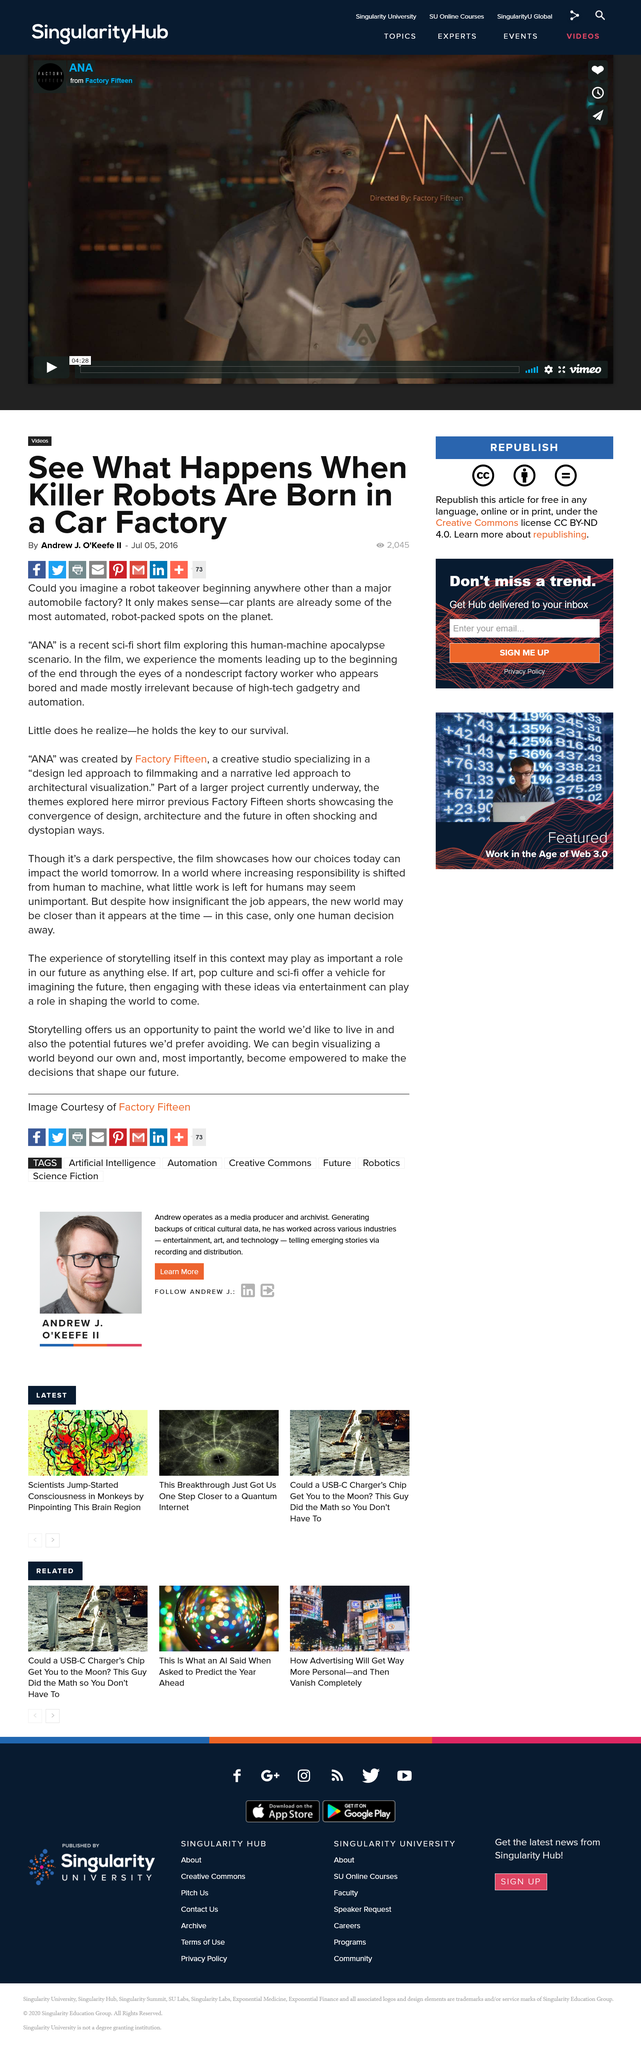Highlight a few significant elements in this photo. This article's title is 'What is the name of the title of the article? See What Happens When Killer Robots Are Born in a Car Factory..' The author of this article is Andrew J. O'Keefe II. This article was created on July 05, 2016. 